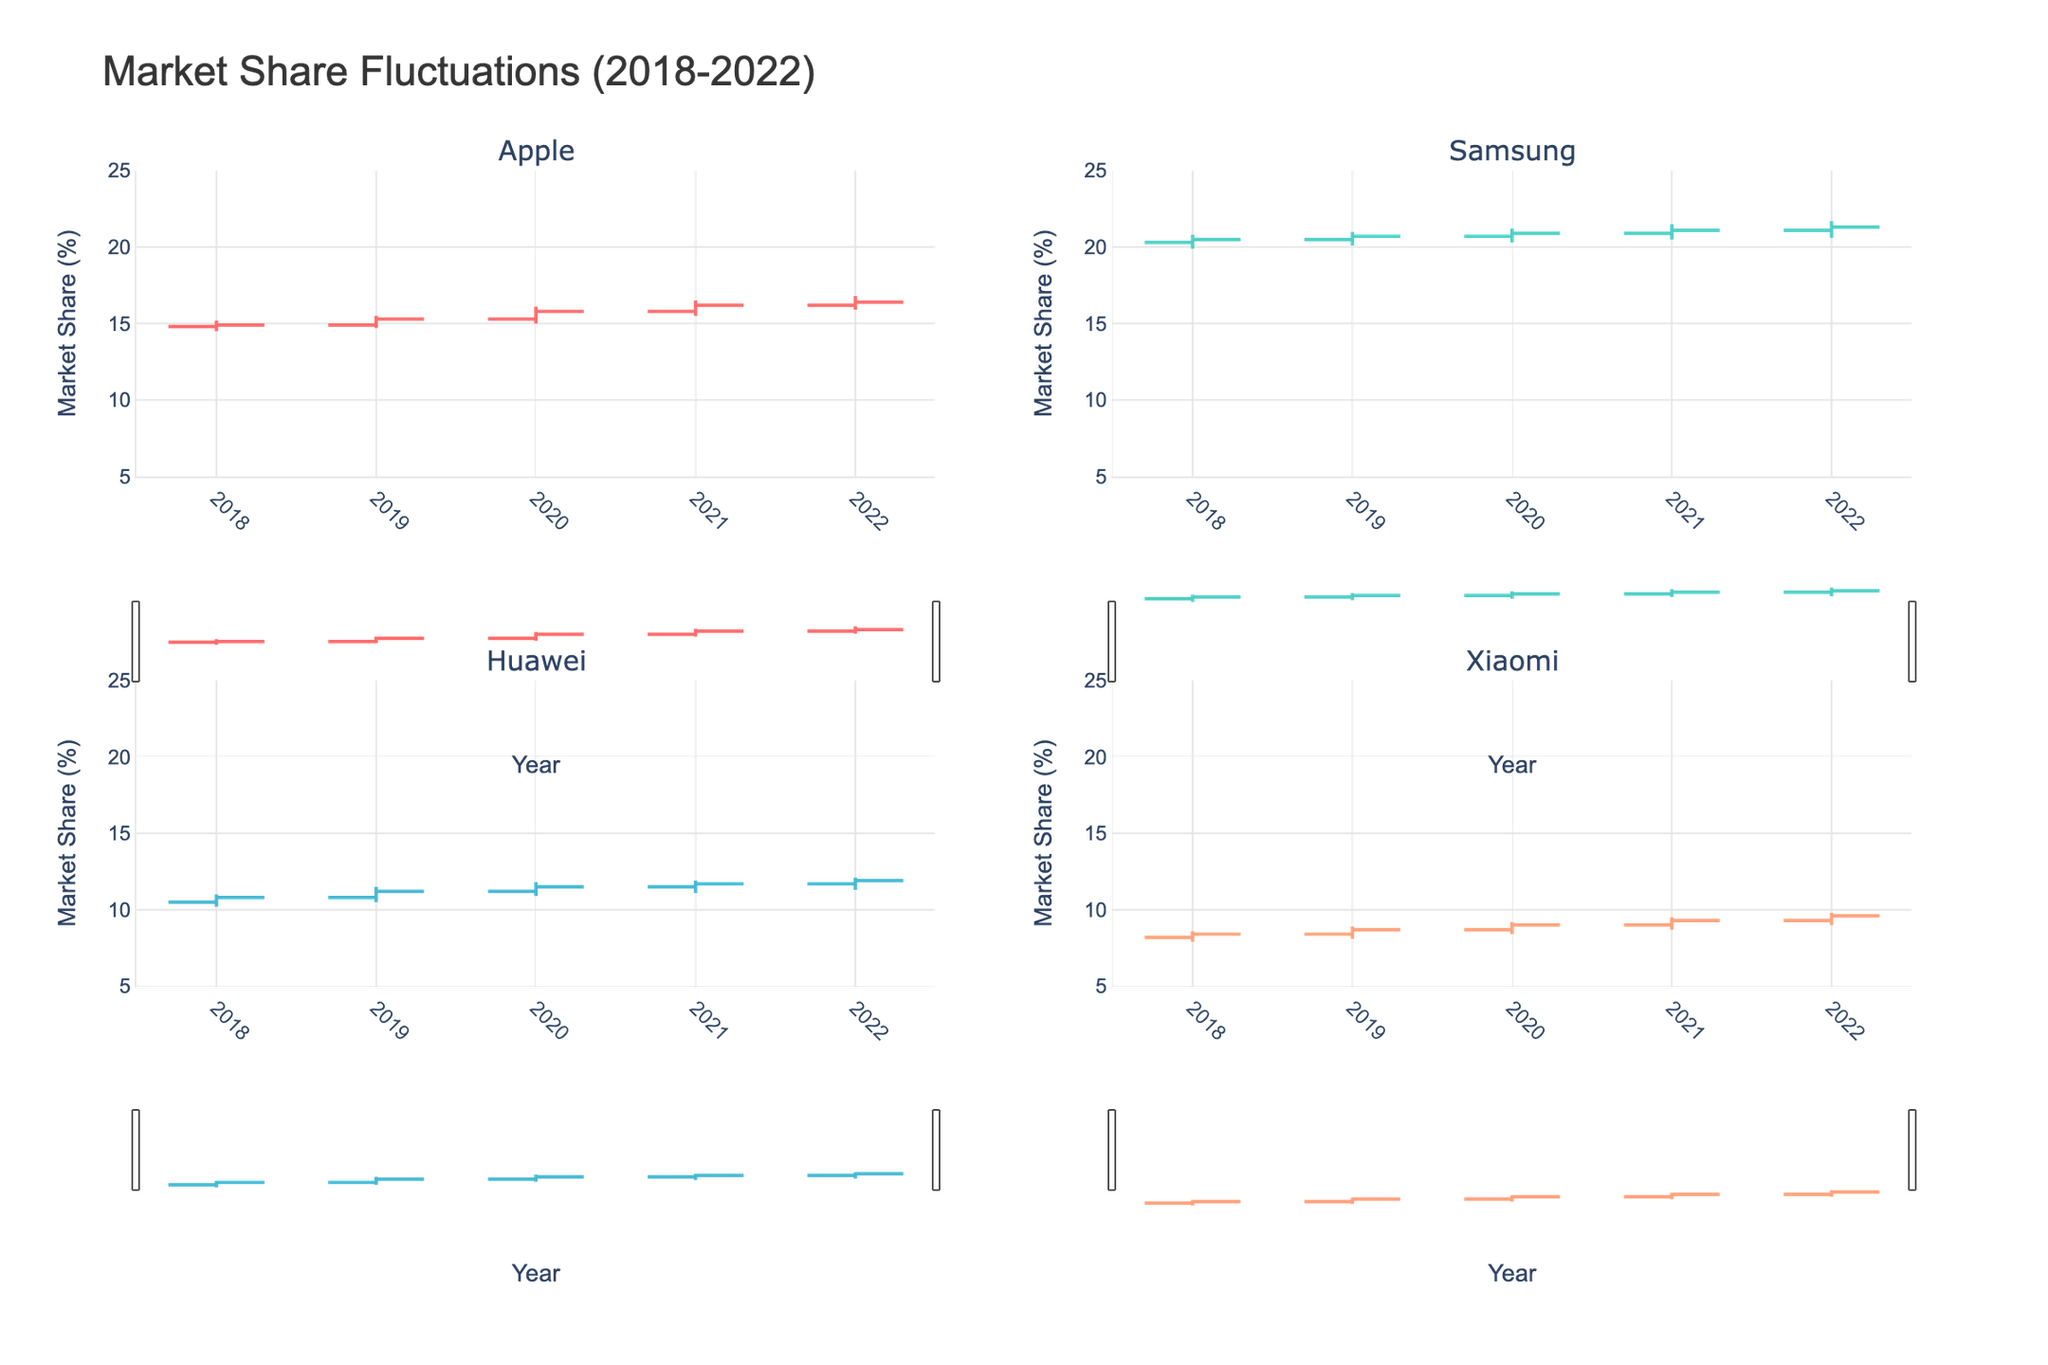What is the title of the figure? The title of the figure is prominently displayed at the top of the chart. It reads "Market Share Fluctuations (2018-2022)"
Answer: Market Share Fluctuations (2018-2022) How many subplots are in the figure? The figure is divided into multiple subplots, showing one for each company. There are four unique companies listed in the data, thus four subplots are present in a 2x2 grid format
Answer: Four Which company had the highest market share in 2022? According to the OHLC bars, Samsung had the highest market share in 2022, with the closing value close to 21.3%
Answer: Samsung Compare Apple and Huawei in terms of their market share trends over the years. For Apple, market share gradually increased from 14.9% in 2018 to 16.4% in 2022. For Huawei, although there were fluctuations, the market share also increased from 10.8% in 2018 to 11.9% in 2022
Answer: Both experienced an upward trend, but Apple gained more What was the lowest market share recorded for Xiaomi in the given years? The OHLC chart for Xiaomi shows that the lowest market share recorded was 7.9% in 2018
Answer: 7.9% Which company showed the smallest range of market share fluctuations in 2020? In the OHLC subplots, Huawei shows the smallest range with 11.2% as open and 11.8% as high, making the range 0.6%
Answer: Huawei Between 2019 and 2020, which company had the greatest increase in its closing market share? In the OHLC charts, Apple's closing market share increased from 14.9% in 2019 to 15.8% in 2020, amounting to a 0.9% increase, the highest among all companies
Answer: Apple What is the average closing market share for Samsung from 2018 to 2022? Samsung's closing shares are 20.5%, 20.7%, 20.9%, 21.1%, and 21.3%. The average is calculated as (20.5 + 20.7 + 20.9 + 21.1 + 21.3) / 5 = 20.9%
Answer: 20.9% Which year did Apple see its highest market share? In Apple's OHLC subplot, the year with the highest market share is 2022 with a closing of 16.4%, which is higher than in other years
Answer: 2022 